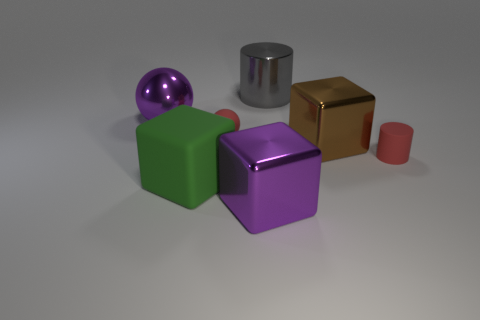How many things are either purple things on the right side of the large ball or gray things?
Your response must be concise. 2. Is the number of large cylinders in front of the brown object less than the number of matte spheres that are to the right of the green block?
Your response must be concise. Yes. What number of other things are the same size as the red sphere?
Keep it short and to the point. 1. Do the gray cylinder and the ball that is right of the purple metallic sphere have the same material?
Ensure brevity in your answer.  No. What number of objects are cylinders in front of the big gray object or big metal things that are behind the small sphere?
Ensure brevity in your answer.  3. The metallic cylinder has what color?
Provide a succinct answer. Gray. Are there fewer large green matte things that are to the right of the big brown shiny object than cyan objects?
Give a very brief answer. No. Is there a tiny brown metal cylinder?
Ensure brevity in your answer.  No. Are there fewer metallic objects than small red things?
Provide a succinct answer. No. What number of red cylinders are made of the same material as the large ball?
Provide a succinct answer. 0. 